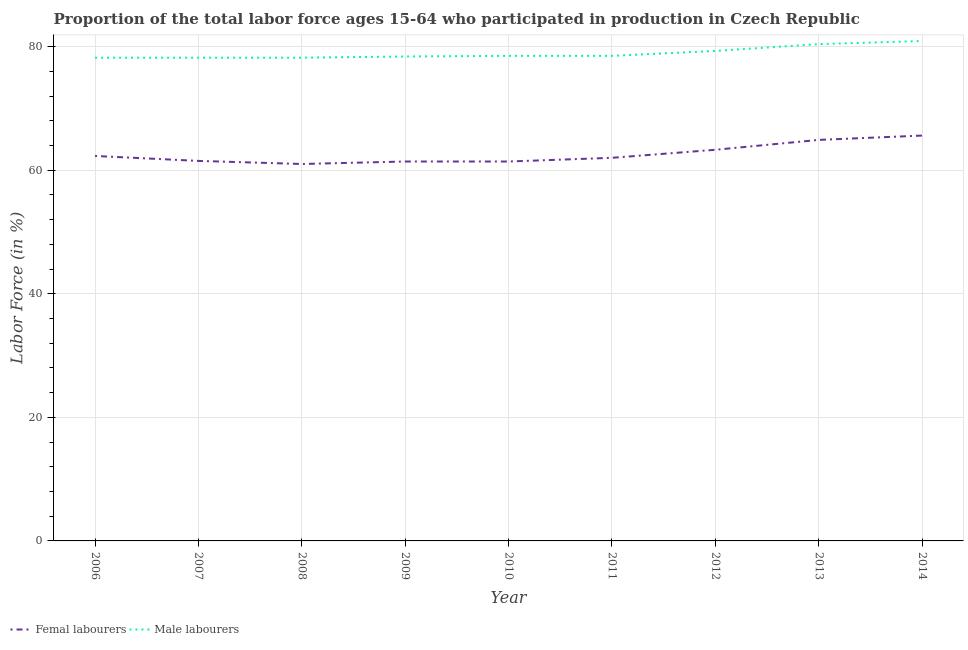How many different coloured lines are there?
Your answer should be very brief. 2. What is the percentage of male labour force in 2009?
Give a very brief answer. 78.4. Across all years, what is the maximum percentage of female labor force?
Ensure brevity in your answer.  65.6. Across all years, what is the minimum percentage of male labour force?
Make the answer very short. 78.2. In which year was the percentage of female labor force minimum?
Provide a succinct answer. 2008. What is the total percentage of female labor force in the graph?
Your answer should be very brief. 563.4. What is the difference between the percentage of female labor force in 2010 and that in 2012?
Give a very brief answer. -1.9. What is the difference between the percentage of male labour force in 2007 and the percentage of female labor force in 2010?
Your answer should be compact. 16.8. What is the average percentage of female labor force per year?
Keep it short and to the point. 62.6. In the year 2008, what is the difference between the percentage of female labor force and percentage of male labour force?
Make the answer very short. -17.2. What is the ratio of the percentage of male labour force in 2009 to that in 2014?
Ensure brevity in your answer.  0.97. Is the percentage of male labour force in 2012 less than that in 2013?
Provide a short and direct response. Yes. Is the difference between the percentage of female labor force in 2009 and 2010 greater than the difference between the percentage of male labour force in 2009 and 2010?
Keep it short and to the point. Yes. What is the difference between the highest and the second highest percentage of female labor force?
Your answer should be very brief. 0.7. What is the difference between the highest and the lowest percentage of male labour force?
Your response must be concise. 2.7. Is the sum of the percentage of male labour force in 2009 and 2012 greater than the maximum percentage of female labor force across all years?
Offer a terse response. Yes. Does the percentage of male labour force monotonically increase over the years?
Give a very brief answer. No. Is the percentage of male labour force strictly greater than the percentage of female labor force over the years?
Provide a short and direct response. Yes. Is the percentage of male labour force strictly less than the percentage of female labor force over the years?
Offer a terse response. No. How many years are there in the graph?
Make the answer very short. 9. Where does the legend appear in the graph?
Your answer should be very brief. Bottom left. How many legend labels are there?
Keep it short and to the point. 2. How are the legend labels stacked?
Make the answer very short. Horizontal. What is the title of the graph?
Give a very brief answer. Proportion of the total labor force ages 15-64 who participated in production in Czech Republic. Does "Constant 2005 US$" appear as one of the legend labels in the graph?
Give a very brief answer. No. What is the label or title of the X-axis?
Your answer should be compact. Year. What is the Labor Force (in %) of Femal labourers in 2006?
Keep it short and to the point. 62.3. What is the Labor Force (in %) of Male labourers in 2006?
Your answer should be very brief. 78.2. What is the Labor Force (in %) of Femal labourers in 2007?
Provide a succinct answer. 61.5. What is the Labor Force (in %) of Male labourers in 2007?
Ensure brevity in your answer.  78.2. What is the Labor Force (in %) in Male labourers in 2008?
Your response must be concise. 78.2. What is the Labor Force (in %) of Femal labourers in 2009?
Ensure brevity in your answer.  61.4. What is the Labor Force (in %) of Male labourers in 2009?
Provide a succinct answer. 78.4. What is the Labor Force (in %) in Femal labourers in 2010?
Provide a succinct answer. 61.4. What is the Labor Force (in %) in Male labourers in 2010?
Your answer should be compact. 78.5. What is the Labor Force (in %) of Male labourers in 2011?
Give a very brief answer. 78.5. What is the Labor Force (in %) of Femal labourers in 2012?
Keep it short and to the point. 63.3. What is the Labor Force (in %) in Male labourers in 2012?
Give a very brief answer. 79.3. What is the Labor Force (in %) of Femal labourers in 2013?
Your answer should be very brief. 64.9. What is the Labor Force (in %) in Male labourers in 2013?
Your answer should be compact. 80.4. What is the Labor Force (in %) of Femal labourers in 2014?
Offer a terse response. 65.6. What is the Labor Force (in %) in Male labourers in 2014?
Make the answer very short. 80.9. Across all years, what is the maximum Labor Force (in %) of Femal labourers?
Keep it short and to the point. 65.6. Across all years, what is the maximum Labor Force (in %) of Male labourers?
Offer a very short reply. 80.9. Across all years, what is the minimum Labor Force (in %) in Femal labourers?
Your answer should be compact. 61. Across all years, what is the minimum Labor Force (in %) in Male labourers?
Give a very brief answer. 78.2. What is the total Labor Force (in %) of Femal labourers in the graph?
Provide a short and direct response. 563.4. What is the total Labor Force (in %) in Male labourers in the graph?
Offer a very short reply. 710.6. What is the difference between the Labor Force (in %) in Male labourers in 2006 and that in 2009?
Your response must be concise. -0.2. What is the difference between the Labor Force (in %) in Male labourers in 2006 and that in 2010?
Offer a terse response. -0.3. What is the difference between the Labor Force (in %) of Male labourers in 2006 and that in 2011?
Your answer should be compact. -0.3. What is the difference between the Labor Force (in %) of Femal labourers in 2006 and that in 2012?
Offer a terse response. -1. What is the difference between the Labor Force (in %) of Male labourers in 2006 and that in 2012?
Your response must be concise. -1.1. What is the difference between the Labor Force (in %) in Femal labourers in 2006 and that in 2013?
Your answer should be very brief. -2.6. What is the difference between the Labor Force (in %) in Male labourers in 2006 and that in 2013?
Provide a short and direct response. -2.2. What is the difference between the Labor Force (in %) in Femal labourers in 2007 and that in 2008?
Provide a short and direct response. 0.5. What is the difference between the Labor Force (in %) in Male labourers in 2007 and that in 2008?
Make the answer very short. 0. What is the difference between the Labor Force (in %) in Male labourers in 2007 and that in 2009?
Your answer should be compact. -0.2. What is the difference between the Labor Force (in %) in Femal labourers in 2007 and that in 2010?
Provide a short and direct response. 0.1. What is the difference between the Labor Force (in %) of Male labourers in 2007 and that in 2010?
Provide a succinct answer. -0.3. What is the difference between the Labor Force (in %) in Femal labourers in 2007 and that in 2012?
Your response must be concise. -1.8. What is the difference between the Labor Force (in %) in Male labourers in 2007 and that in 2013?
Your answer should be compact. -2.2. What is the difference between the Labor Force (in %) in Femal labourers in 2007 and that in 2014?
Offer a very short reply. -4.1. What is the difference between the Labor Force (in %) of Femal labourers in 2008 and that in 2009?
Give a very brief answer. -0.4. What is the difference between the Labor Force (in %) of Male labourers in 2008 and that in 2009?
Provide a succinct answer. -0.2. What is the difference between the Labor Force (in %) of Femal labourers in 2008 and that in 2010?
Your response must be concise. -0.4. What is the difference between the Labor Force (in %) of Male labourers in 2008 and that in 2010?
Your answer should be compact. -0.3. What is the difference between the Labor Force (in %) of Male labourers in 2008 and that in 2011?
Keep it short and to the point. -0.3. What is the difference between the Labor Force (in %) of Femal labourers in 2008 and that in 2012?
Provide a short and direct response. -2.3. What is the difference between the Labor Force (in %) in Male labourers in 2008 and that in 2012?
Offer a very short reply. -1.1. What is the difference between the Labor Force (in %) in Male labourers in 2008 and that in 2013?
Your answer should be very brief. -2.2. What is the difference between the Labor Force (in %) in Male labourers in 2008 and that in 2014?
Your response must be concise. -2.7. What is the difference between the Labor Force (in %) of Male labourers in 2009 and that in 2010?
Provide a short and direct response. -0.1. What is the difference between the Labor Force (in %) of Femal labourers in 2009 and that in 2013?
Make the answer very short. -3.5. What is the difference between the Labor Force (in %) of Male labourers in 2009 and that in 2013?
Provide a short and direct response. -2. What is the difference between the Labor Force (in %) of Male labourers in 2010 and that in 2012?
Keep it short and to the point. -0.8. What is the difference between the Labor Force (in %) of Femal labourers in 2010 and that in 2013?
Give a very brief answer. -3.5. What is the difference between the Labor Force (in %) in Male labourers in 2010 and that in 2013?
Provide a succinct answer. -1.9. What is the difference between the Labor Force (in %) of Male labourers in 2011 and that in 2012?
Provide a succinct answer. -0.8. What is the difference between the Labor Force (in %) of Femal labourers in 2011 and that in 2014?
Offer a very short reply. -3.6. What is the difference between the Labor Force (in %) of Male labourers in 2012 and that in 2014?
Your answer should be compact. -1.6. What is the difference between the Labor Force (in %) of Femal labourers in 2013 and that in 2014?
Keep it short and to the point. -0.7. What is the difference between the Labor Force (in %) in Femal labourers in 2006 and the Labor Force (in %) in Male labourers in 2007?
Offer a terse response. -15.9. What is the difference between the Labor Force (in %) of Femal labourers in 2006 and the Labor Force (in %) of Male labourers in 2008?
Give a very brief answer. -15.9. What is the difference between the Labor Force (in %) in Femal labourers in 2006 and the Labor Force (in %) in Male labourers in 2009?
Provide a short and direct response. -16.1. What is the difference between the Labor Force (in %) of Femal labourers in 2006 and the Labor Force (in %) of Male labourers in 2010?
Ensure brevity in your answer.  -16.2. What is the difference between the Labor Force (in %) in Femal labourers in 2006 and the Labor Force (in %) in Male labourers in 2011?
Ensure brevity in your answer.  -16.2. What is the difference between the Labor Force (in %) of Femal labourers in 2006 and the Labor Force (in %) of Male labourers in 2012?
Make the answer very short. -17. What is the difference between the Labor Force (in %) of Femal labourers in 2006 and the Labor Force (in %) of Male labourers in 2013?
Make the answer very short. -18.1. What is the difference between the Labor Force (in %) of Femal labourers in 2006 and the Labor Force (in %) of Male labourers in 2014?
Your response must be concise. -18.6. What is the difference between the Labor Force (in %) in Femal labourers in 2007 and the Labor Force (in %) in Male labourers in 2008?
Offer a terse response. -16.7. What is the difference between the Labor Force (in %) in Femal labourers in 2007 and the Labor Force (in %) in Male labourers in 2009?
Make the answer very short. -16.9. What is the difference between the Labor Force (in %) of Femal labourers in 2007 and the Labor Force (in %) of Male labourers in 2010?
Provide a succinct answer. -17. What is the difference between the Labor Force (in %) in Femal labourers in 2007 and the Labor Force (in %) in Male labourers in 2011?
Ensure brevity in your answer.  -17. What is the difference between the Labor Force (in %) in Femal labourers in 2007 and the Labor Force (in %) in Male labourers in 2012?
Your answer should be compact. -17.8. What is the difference between the Labor Force (in %) of Femal labourers in 2007 and the Labor Force (in %) of Male labourers in 2013?
Give a very brief answer. -18.9. What is the difference between the Labor Force (in %) of Femal labourers in 2007 and the Labor Force (in %) of Male labourers in 2014?
Make the answer very short. -19.4. What is the difference between the Labor Force (in %) of Femal labourers in 2008 and the Labor Force (in %) of Male labourers in 2009?
Provide a succinct answer. -17.4. What is the difference between the Labor Force (in %) of Femal labourers in 2008 and the Labor Force (in %) of Male labourers in 2010?
Offer a terse response. -17.5. What is the difference between the Labor Force (in %) of Femal labourers in 2008 and the Labor Force (in %) of Male labourers in 2011?
Your answer should be compact. -17.5. What is the difference between the Labor Force (in %) in Femal labourers in 2008 and the Labor Force (in %) in Male labourers in 2012?
Keep it short and to the point. -18.3. What is the difference between the Labor Force (in %) in Femal labourers in 2008 and the Labor Force (in %) in Male labourers in 2013?
Provide a short and direct response. -19.4. What is the difference between the Labor Force (in %) of Femal labourers in 2008 and the Labor Force (in %) of Male labourers in 2014?
Give a very brief answer. -19.9. What is the difference between the Labor Force (in %) in Femal labourers in 2009 and the Labor Force (in %) in Male labourers in 2010?
Your response must be concise. -17.1. What is the difference between the Labor Force (in %) in Femal labourers in 2009 and the Labor Force (in %) in Male labourers in 2011?
Your response must be concise. -17.1. What is the difference between the Labor Force (in %) of Femal labourers in 2009 and the Labor Force (in %) of Male labourers in 2012?
Your answer should be compact. -17.9. What is the difference between the Labor Force (in %) in Femal labourers in 2009 and the Labor Force (in %) in Male labourers in 2013?
Keep it short and to the point. -19. What is the difference between the Labor Force (in %) in Femal labourers in 2009 and the Labor Force (in %) in Male labourers in 2014?
Offer a terse response. -19.5. What is the difference between the Labor Force (in %) of Femal labourers in 2010 and the Labor Force (in %) of Male labourers in 2011?
Provide a succinct answer. -17.1. What is the difference between the Labor Force (in %) in Femal labourers in 2010 and the Labor Force (in %) in Male labourers in 2012?
Give a very brief answer. -17.9. What is the difference between the Labor Force (in %) in Femal labourers in 2010 and the Labor Force (in %) in Male labourers in 2014?
Provide a succinct answer. -19.5. What is the difference between the Labor Force (in %) in Femal labourers in 2011 and the Labor Force (in %) in Male labourers in 2012?
Your response must be concise. -17.3. What is the difference between the Labor Force (in %) of Femal labourers in 2011 and the Labor Force (in %) of Male labourers in 2013?
Ensure brevity in your answer.  -18.4. What is the difference between the Labor Force (in %) of Femal labourers in 2011 and the Labor Force (in %) of Male labourers in 2014?
Your answer should be compact. -18.9. What is the difference between the Labor Force (in %) of Femal labourers in 2012 and the Labor Force (in %) of Male labourers in 2013?
Keep it short and to the point. -17.1. What is the difference between the Labor Force (in %) in Femal labourers in 2012 and the Labor Force (in %) in Male labourers in 2014?
Your answer should be very brief. -17.6. What is the average Labor Force (in %) of Femal labourers per year?
Keep it short and to the point. 62.6. What is the average Labor Force (in %) of Male labourers per year?
Provide a succinct answer. 78.96. In the year 2006, what is the difference between the Labor Force (in %) in Femal labourers and Labor Force (in %) in Male labourers?
Keep it short and to the point. -15.9. In the year 2007, what is the difference between the Labor Force (in %) of Femal labourers and Labor Force (in %) of Male labourers?
Provide a succinct answer. -16.7. In the year 2008, what is the difference between the Labor Force (in %) in Femal labourers and Labor Force (in %) in Male labourers?
Offer a terse response. -17.2. In the year 2009, what is the difference between the Labor Force (in %) of Femal labourers and Labor Force (in %) of Male labourers?
Give a very brief answer. -17. In the year 2010, what is the difference between the Labor Force (in %) of Femal labourers and Labor Force (in %) of Male labourers?
Make the answer very short. -17.1. In the year 2011, what is the difference between the Labor Force (in %) of Femal labourers and Labor Force (in %) of Male labourers?
Offer a very short reply. -16.5. In the year 2013, what is the difference between the Labor Force (in %) in Femal labourers and Labor Force (in %) in Male labourers?
Give a very brief answer. -15.5. In the year 2014, what is the difference between the Labor Force (in %) of Femal labourers and Labor Force (in %) of Male labourers?
Ensure brevity in your answer.  -15.3. What is the ratio of the Labor Force (in %) in Femal labourers in 2006 to that in 2008?
Your answer should be compact. 1.02. What is the ratio of the Labor Force (in %) of Femal labourers in 2006 to that in 2009?
Your answer should be compact. 1.01. What is the ratio of the Labor Force (in %) of Femal labourers in 2006 to that in 2010?
Your answer should be very brief. 1.01. What is the ratio of the Labor Force (in %) in Femal labourers in 2006 to that in 2012?
Your response must be concise. 0.98. What is the ratio of the Labor Force (in %) in Male labourers in 2006 to that in 2012?
Your answer should be compact. 0.99. What is the ratio of the Labor Force (in %) of Femal labourers in 2006 to that in 2013?
Your answer should be compact. 0.96. What is the ratio of the Labor Force (in %) of Male labourers in 2006 to that in 2013?
Your answer should be compact. 0.97. What is the ratio of the Labor Force (in %) of Femal labourers in 2006 to that in 2014?
Provide a short and direct response. 0.95. What is the ratio of the Labor Force (in %) of Male labourers in 2006 to that in 2014?
Make the answer very short. 0.97. What is the ratio of the Labor Force (in %) of Femal labourers in 2007 to that in 2008?
Keep it short and to the point. 1.01. What is the ratio of the Labor Force (in %) in Femal labourers in 2007 to that in 2009?
Your answer should be very brief. 1. What is the ratio of the Labor Force (in %) in Femal labourers in 2007 to that in 2010?
Your answer should be compact. 1. What is the ratio of the Labor Force (in %) in Male labourers in 2007 to that in 2011?
Ensure brevity in your answer.  1. What is the ratio of the Labor Force (in %) in Femal labourers in 2007 to that in 2012?
Give a very brief answer. 0.97. What is the ratio of the Labor Force (in %) of Male labourers in 2007 to that in 2012?
Offer a very short reply. 0.99. What is the ratio of the Labor Force (in %) of Femal labourers in 2007 to that in 2013?
Keep it short and to the point. 0.95. What is the ratio of the Labor Force (in %) of Male labourers in 2007 to that in 2013?
Your answer should be compact. 0.97. What is the ratio of the Labor Force (in %) in Femal labourers in 2007 to that in 2014?
Ensure brevity in your answer.  0.94. What is the ratio of the Labor Force (in %) in Male labourers in 2007 to that in 2014?
Offer a terse response. 0.97. What is the ratio of the Labor Force (in %) in Femal labourers in 2008 to that in 2010?
Your answer should be very brief. 0.99. What is the ratio of the Labor Force (in %) of Male labourers in 2008 to that in 2010?
Keep it short and to the point. 1. What is the ratio of the Labor Force (in %) of Femal labourers in 2008 to that in 2011?
Keep it short and to the point. 0.98. What is the ratio of the Labor Force (in %) in Male labourers in 2008 to that in 2011?
Make the answer very short. 1. What is the ratio of the Labor Force (in %) in Femal labourers in 2008 to that in 2012?
Your response must be concise. 0.96. What is the ratio of the Labor Force (in %) of Male labourers in 2008 to that in 2012?
Keep it short and to the point. 0.99. What is the ratio of the Labor Force (in %) in Femal labourers in 2008 to that in 2013?
Give a very brief answer. 0.94. What is the ratio of the Labor Force (in %) in Male labourers in 2008 to that in 2013?
Your answer should be compact. 0.97. What is the ratio of the Labor Force (in %) in Femal labourers in 2008 to that in 2014?
Make the answer very short. 0.93. What is the ratio of the Labor Force (in %) in Male labourers in 2008 to that in 2014?
Give a very brief answer. 0.97. What is the ratio of the Labor Force (in %) of Femal labourers in 2009 to that in 2010?
Your answer should be compact. 1. What is the ratio of the Labor Force (in %) of Femal labourers in 2009 to that in 2011?
Your answer should be very brief. 0.99. What is the ratio of the Labor Force (in %) of Male labourers in 2009 to that in 2011?
Make the answer very short. 1. What is the ratio of the Labor Force (in %) in Male labourers in 2009 to that in 2012?
Give a very brief answer. 0.99. What is the ratio of the Labor Force (in %) in Femal labourers in 2009 to that in 2013?
Offer a terse response. 0.95. What is the ratio of the Labor Force (in %) in Male labourers in 2009 to that in 2013?
Your answer should be very brief. 0.98. What is the ratio of the Labor Force (in %) in Femal labourers in 2009 to that in 2014?
Your answer should be compact. 0.94. What is the ratio of the Labor Force (in %) in Male labourers in 2009 to that in 2014?
Your answer should be compact. 0.97. What is the ratio of the Labor Force (in %) in Femal labourers in 2010 to that in 2011?
Your response must be concise. 0.99. What is the ratio of the Labor Force (in %) in Male labourers in 2010 to that in 2012?
Keep it short and to the point. 0.99. What is the ratio of the Labor Force (in %) of Femal labourers in 2010 to that in 2013?
Ensure brevity in your answer.  0.95. What is the ratio of the Labor Force (in %) in Male labourers in 2010 to that in 2013?
Provide a succinct answer. 0.98. What is the ratio of the Labor Force (in %) of Femal labourers in 2010 to that in 2014?
Give a very brief answer. 0.94. What is the ratio of the Labor Force (in %) of Male labourers in 2010 to that in 2014?
Give a very brief answer. 0.97. What is the ratio of the Labor Force (in %) of Femal labourers in 2011 to that in 2012?
Offer a very short reply. 0.98. What is the ratio of the Labor Force (in %) of Male labourers in 2011 to that in 2012?
Make the answer very short. 0.99. What is the ratio of the Labor Force (in %) in Femal labourers in 2011 to that in 2013?
Keep it short and to the point. 0.96. What is the ratio of the Labor Force (in %) of Male labourers in 2011 to that in 2013?
Ensure brevity in your answer.  0.98. What is the ratio of the Labor Force (in %) of Femal labourers in 2011 to that in 2014?
Provide a short and direct response. 0.95. What is the ratio of the Labor Force (in %) in Male labourers in 2011 to that in 2014?
Your answer should be compact. 0.97. What is the ratio of the Labor Force (in %) of Femal labourers in 2012 to that in 2013?
Offer a very short reply. 0.98. What is the ratio of the Labor Force (in %) of Male labourers in 2012 to that in 2013?
Offer a terse response. 0.99. What is the ratio of the Labor Force (in %) in Femal labourers in 2012 to that in 2014?
Your answer should be very brief. 0.96. What is the ratio of the Labor Force (in %) in Male labourers in 2012 to that in 2014?
Your response must be concise. 0.98. What is the ratio of the Labor Force (in %) of Femal labourers in 2013 to that in 2014?
Your answer should be compact. 0.99. What is the difference between the highest and the second highest Labor Force (in %) of Femal labourers?
Your response must be concise. 0.7. What is the difference between the highest and the lowest Labor Force (in %) of Femal labourers?
Your answer should be compact. 4.6. What is the difference between the highest and the lowest Labor Force (in %) of Male labourers?
Ensure brevity in your answer.  2.7. 